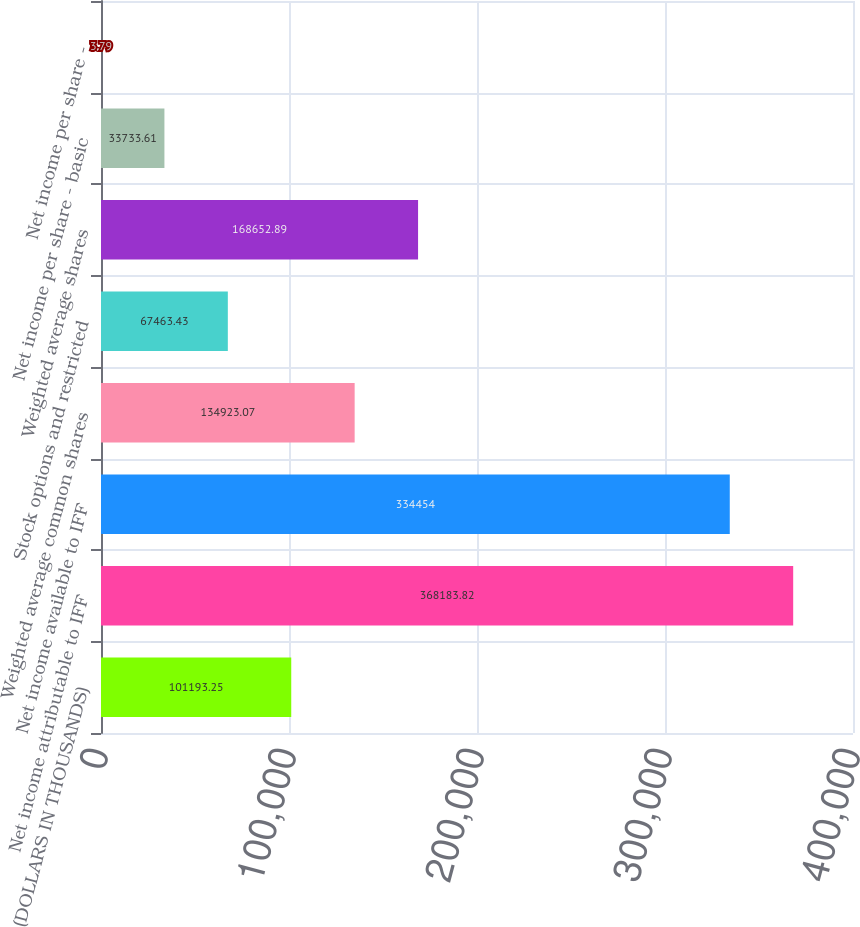Convert chart to OTSL. <chart><loc_0><loc_0><loc_500><loc_500><bar_chart><fcel>(DOLLARS IN THOUSANDS)<fcel>Net income attributable to IFF<fcel>Net income available to IFF<fcel>Weighted average common shares<fcel>Stock options and restricted<fcel>Weighted average shares<fcel>Net income per share - basic<fcel>Net income per share -<nl><fcel>101193<fcel>368184<fcel>334454<fcel>134923<fcel>67463.4<fcel>168653<fcel>33733.6<fcel>3.79<nl></chart> 